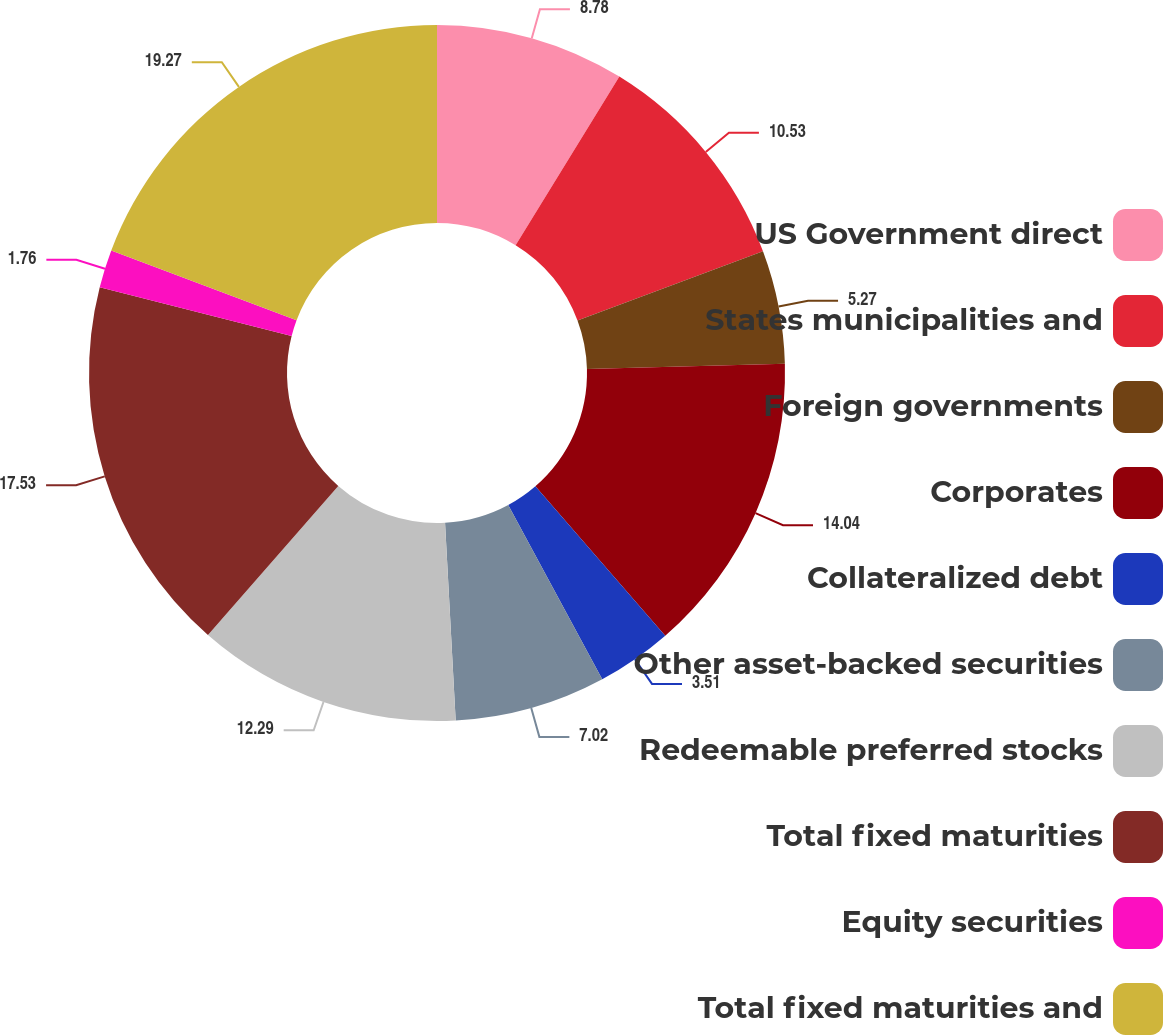Convert chart. <chart><loc_0><loc_0><loc_500><loc_500><pie_chart><fcel>US Government direct<fcel>States municipalities and<fcel>Foreign governments<fcel>Corporates<fcel>Collateralized debt<fcel>Other asset-backed securities<fcel>Redeemable preferred stocks<fcel>Total fixed maturities<fcel>Equity securities<fcel>Total fixed maturities and<nl><fcel>8.78%<fcel>10.53%<fcel>5.27%<fcel>14.04%<fcel>3.51%<fcel>7.02%<fcel>12.29%<fcel>17.53%<fcel>1.76%<fcel>19.28%<nl></chart> 